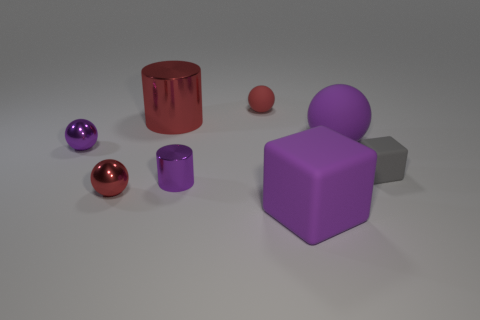Add 1 purple metal spheres. How many objects exist? 9 Subtract all cubes. How many objects are left? 6 Subtract all large red metal cylinders. Subtract all tiny red metal spheres. How many objects are left? 6 Add 5 large shiny objects. How many large shiny objects are left? 6 Add 4 big brown metal objects. How many big brown metal objects exist? 4 Subtract 0 green cylinders. How many objects are left? 8 